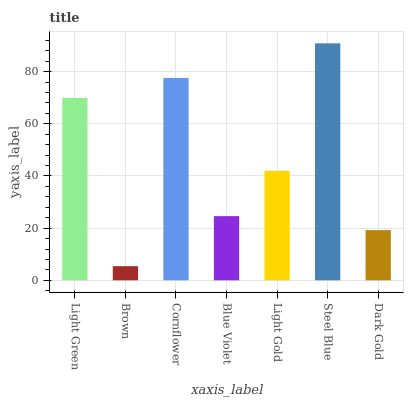Is Brown the minimum?
Answer yes or no. Yes. Is Steel Blue the maximum?
Answer yes or no. Yes. Is Cornflower the minimum?
Answer yes or no. No. Is Cornflower the maximum?
Answer yes or no. No. Is Cornflower greater than Brown?
Answer yes or no. Yes. Is Brown less than Cornflower?
Answer yes or no. Yes. Is Brown greater than Cornflower?
Answer yes or no. No. Is Cornflower less than Brown?
Answer yes or no. No. Is Light Gold the high median?
Answer yes or no. Yes. Is Light Gold the low median?
Answer yes or no. Yes. Is Blue Violet the high median?
Answer yes or no. No. Is Light Green the low median?
Answer yes or no. No. 